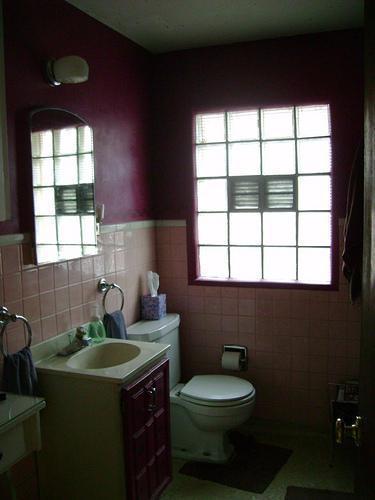How many windows are there?
Give a very brief answer. 1. How many cups are on the table?
Give a very brief answer. 0. 